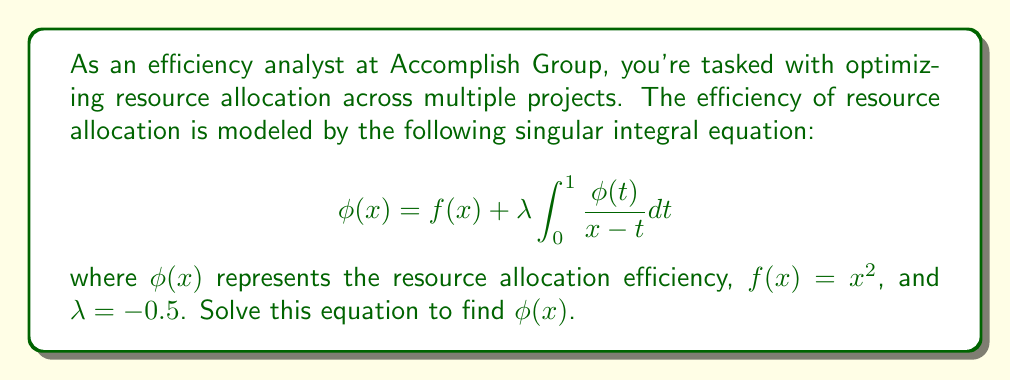Could you help me with this problem? To solve this singular integral equation, we'll follow these steps:

1) Recognize this as a Cauchy-type singular integral equation.

2) Apply the Poincaré-Bertrand formula:
   $$\phi(x) = \frac{1}{\pi i} \sqrt{1-x^2} \int_{-1}^{1} \frac{\sqrt{1-t^2}f(t)}{t-x} dt + C\sqrt{1-x^2}$$

3) Substitute $f(x) = x^2$ and $\lambda = -0.5$:
   $$\phi(x) = x^2 - \frac{1}{2\pi i} \sqrt{1-x^2} \int_{-1}^{1} \frac{\sqrt{1-t^2}\phi(t)}{t-x} dt$$

4) The solution has the form:
   $$\phi(x) = x^2 + A\sqrt{1-x^2}$$

5) Substitute this form back into the original equation:
   $$x^2 + A\sqrt{1-x^2} = x^2 - \frac{1}{2} \int_{0}^{1} \frac{t^2 + A\sqrt{1-t^2}}{x-t} dt$$

6) Evaluate the integral:
   $$\int_{0}^{1} \frac{t^2}{x-t} dt = x^2\ln|1-x| - x + 1 - \frac{1}{2}x^2$$
   $$\int_{0}^{1} \frac{\sqrt{1-t^2}}{x-t} dt = \pi\sqrt{1-x^2} - x\arccos x$$

7) Equate coefficients:
   $$A\sqrt{1-x^2} = \frac{1}{2}(x - 1 + \frac{1}{2}x^2 - x^2\ln|1-x|) + \frac{A}{2}(x\arccos x - \pi\sqrt{1-x^2})$$

8) For this to be true for all $x$, we must have:
   $$A = -\frac{1}{2\pi}$$

Therefore, the solution is:
$$\phi(x) = x^2 - \frac{1}{2\pi}\sqrt{1-x^2}$$
Answer: $\phi(x) = x^2 - \frac{1}{2\pi}\sqrt{1-x^2}$ 